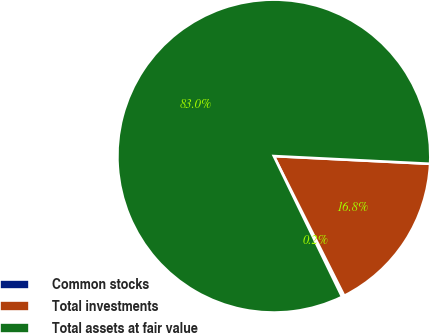Convert chart to OTSL. <chart><loc_0><loc_0><loc_500><loc_500><pie_chart><fcel>Common stocks<fcel>Total investments<fcel>Total assets at fair value<nl><fcel>0.24%<fcel>16.79%<fcel>82.97%<nl></chart> 